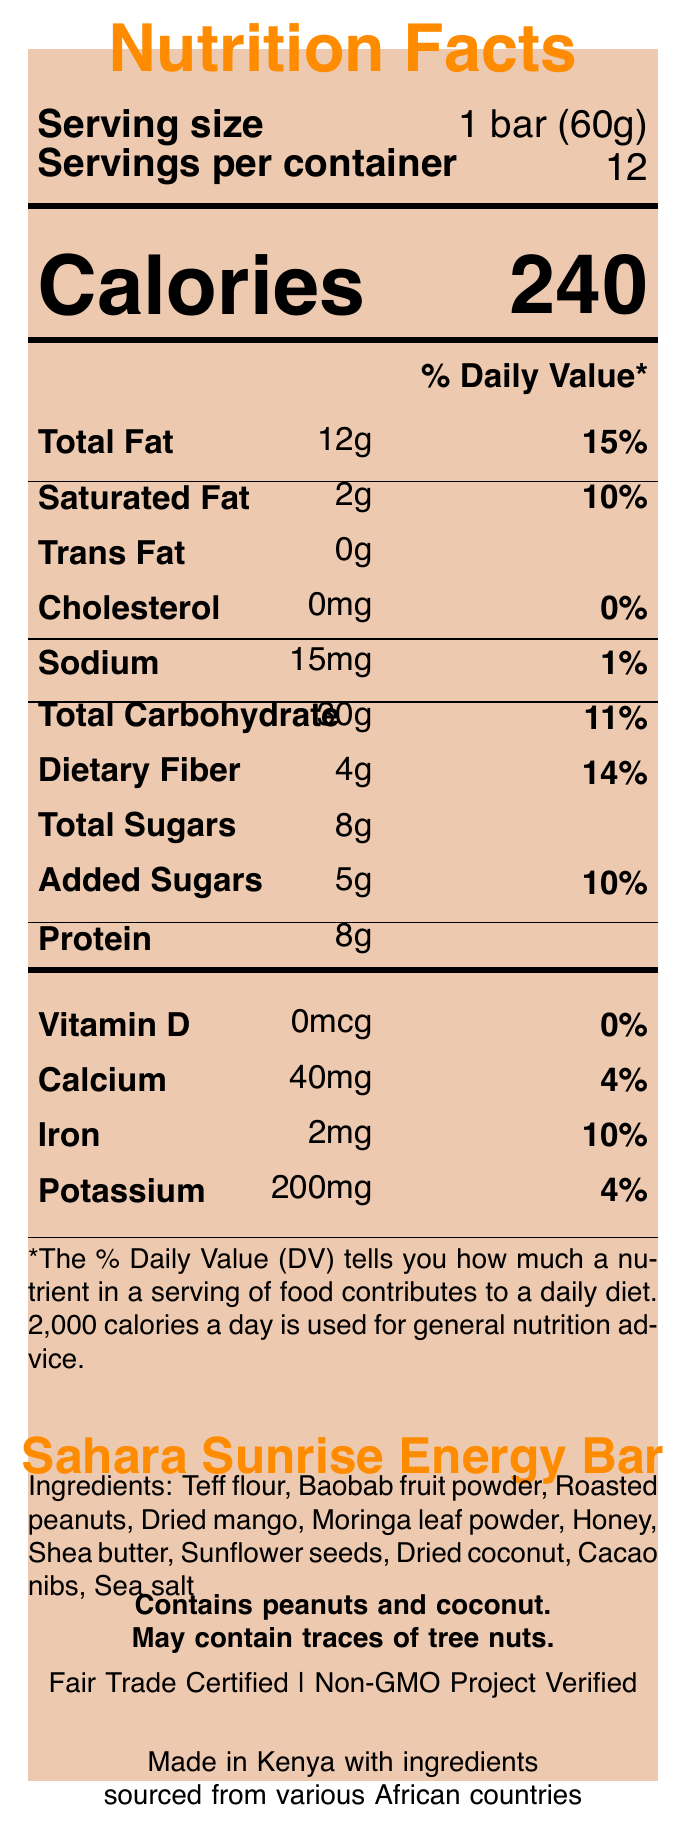What is the serving size of the Sahara Sunrise Energy Bar? The serving size is displayed under the serving size heading.
Answer: 1 bar (60g) How many calories are in one serving of the Sahara Sunrise Energy Bar? The number of calories is displayed prominently below the serving size.
Answer: 240 What is the amount of protein per serving? The protein content is listed under the nutrients section.
Answer: 8g What is the total amount of dietary fiber in the Sahara Sunrise Energy Bar? The dietary fiber content is listed in the nutritional information section.
Answer: 4g Which ingredients contain potential allergens? The allergen information specifically mentions peanuts and coconut.
Answer: Peanuts and coconut What percentage of the daily value for iron does one serving provide? The daily value percentage for iron is listed next to the amount of iron.
Answer: 10% What is the amount of added sugars in one serving? The amount of added sugars is listed in the nutrients section.
Answer: 5g How many servings are there per container? The servings per container are mentioned under the serving size information.
Answer: 12 Does the Sahara Sunrise Energy Bar contain any trans fat? The document lists 0g of trans fat.
Answer: No What is the cultural significance of the Sahara Sunrise Energy Bar? The cultural significance is described at the end of the document.
Answer: Inspired by traditional African superfoods and snacks found in bustling markets across the continent What is the origin of the Sahara Sunrise Energy Bar? The origin is specified at the end of the document.
Answer: Made in Kenya with ingredients sourced from various African countries When should the Sahara Sunrise Energy Bar be consumed for optimal freshness? The storage instructions indicate to consume the product within 3 months of production for optimal freshness.
Answer: Within 3 months of production Which certification does the Sahara Sunrise Energy Bar have? A. USDA Organic B. Non-GMO Project Verified C. Gluten-Free D. Kosher Certified The document indicates that the product is Non-GMO Project Verified.
Answer: B. Non-GMO Project Verified How much calcium is in one serving of the Sahara Sunrise Energy Bar? A. 30mg B. 40mg C. 50mg D. 60mg The amount of calcium per serving is listed in the vitamins and minerals section.
Answer: B. 40mg Is there any cholesterol in the Sahara Sunrise Energy Bar? Yes/No The document lists 0mg of cholesterol, which means there is no cholesterol.
Answer: No Summarize the main information provided by the document. The document offers a comprehensive overview of the Sahara Sunrise Energy Bar’s nutritional content, certifications, ingredient origins, cultural background, allergen details, and consumption instructions.
Answer: The document provides a complete nutrition facts label for the Sahara Sunrise Energy Bar, including serving size, calorie content, nutrient amounts and daily values, allergen information, ingredient list, certifications, cultural significance, sustainability notes, and origin. How many grams of teff flour are used in the Sahara Sunrise Energy Bar? The document lists teff flour as an ingredient but does not specify the amount used.
Answer: Cannot be determined 